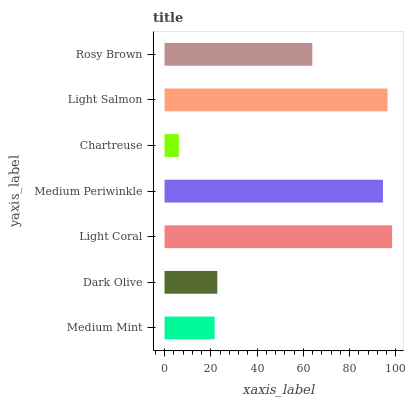Is Chartreuse the minimum?
Answer yes or no. Yes. Is Light Coral the maximum?
Answer yes or no. Yes. Is Dark Olive the minimum?
Answer yes or no. No. Is Dark Olive the maximum?
Answer yes or no. No. Is Dark Olive greater than Medium Mint?
Answer yes or no. Yes. Is Medium Mint less than Dark Olive?
Answer yes or no. Yes. Is Medium Mint greater than Dark Olive?
Answer yes or no. No. Is Dark Olive less than Medium Mint?
Answer yes or no. No. Is Rosy Brown the high median?
Answer yes or no. Yes. Is Rosy Brown the low median?
Answer yes or no. Yes. Is Light Coral the high median?
Answer yes or no. No. Is Dark Olive the low median?
Answer yes or no. No. 